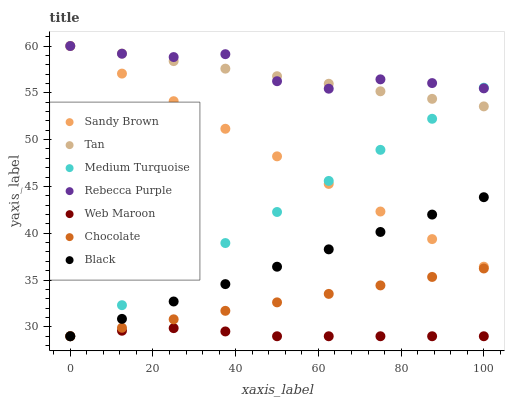Does Web Maroon have the minimum area under the curve?
Answer yes or no. Yes. Does Rebecca Purple have the maximum area under the curve?
Answer yes or no. Yes. Does Chocolate have the minimum area under the curve?
Answer yes or no. No. Does Chocolate have the maximum area under the curve?
Answer yes or no. No. Is Medium Turquoise the smoothest?
Answer yes or no. Yes. Is Rebecca Purple the roughest?
Answer yes or no. Yes. Is Chocolate the smoothest?
Answer yes or no. No. Is Chocolate the roughest?
Answer yes or no. No. Does Web Maroon have the lowest value?
Answer yes or no. Yes. Does Rebecca Purple have the lowest value?
Answer yes or no. No. Does Sandy Brown have the highest value?
Answer yes or no. Yes. Does Chocolate have the highest value?
Answer yes or no. No. Is Chocolate less than Rebecca Purple?
Answer yes or no. Yes. Is Sandy Brown greater than Chocolate?
Answer yes or no. Yes. Does Black intersect Medium Turquoise?
Answer yes or no. Yes. Is Black less than Medium Turquoise?
Answer yes or no. No. Is Black greater than Medium Turquoise?
Answer yes or no. No. Does Chocolate intersect Rebecca Purple?
Answer yes or no. No. 